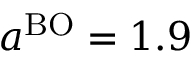Convert formula to latex. <formula><loc_0><loc_0><loc_500><loc_500>a ^ { B O } = 1 . 9</formula> 